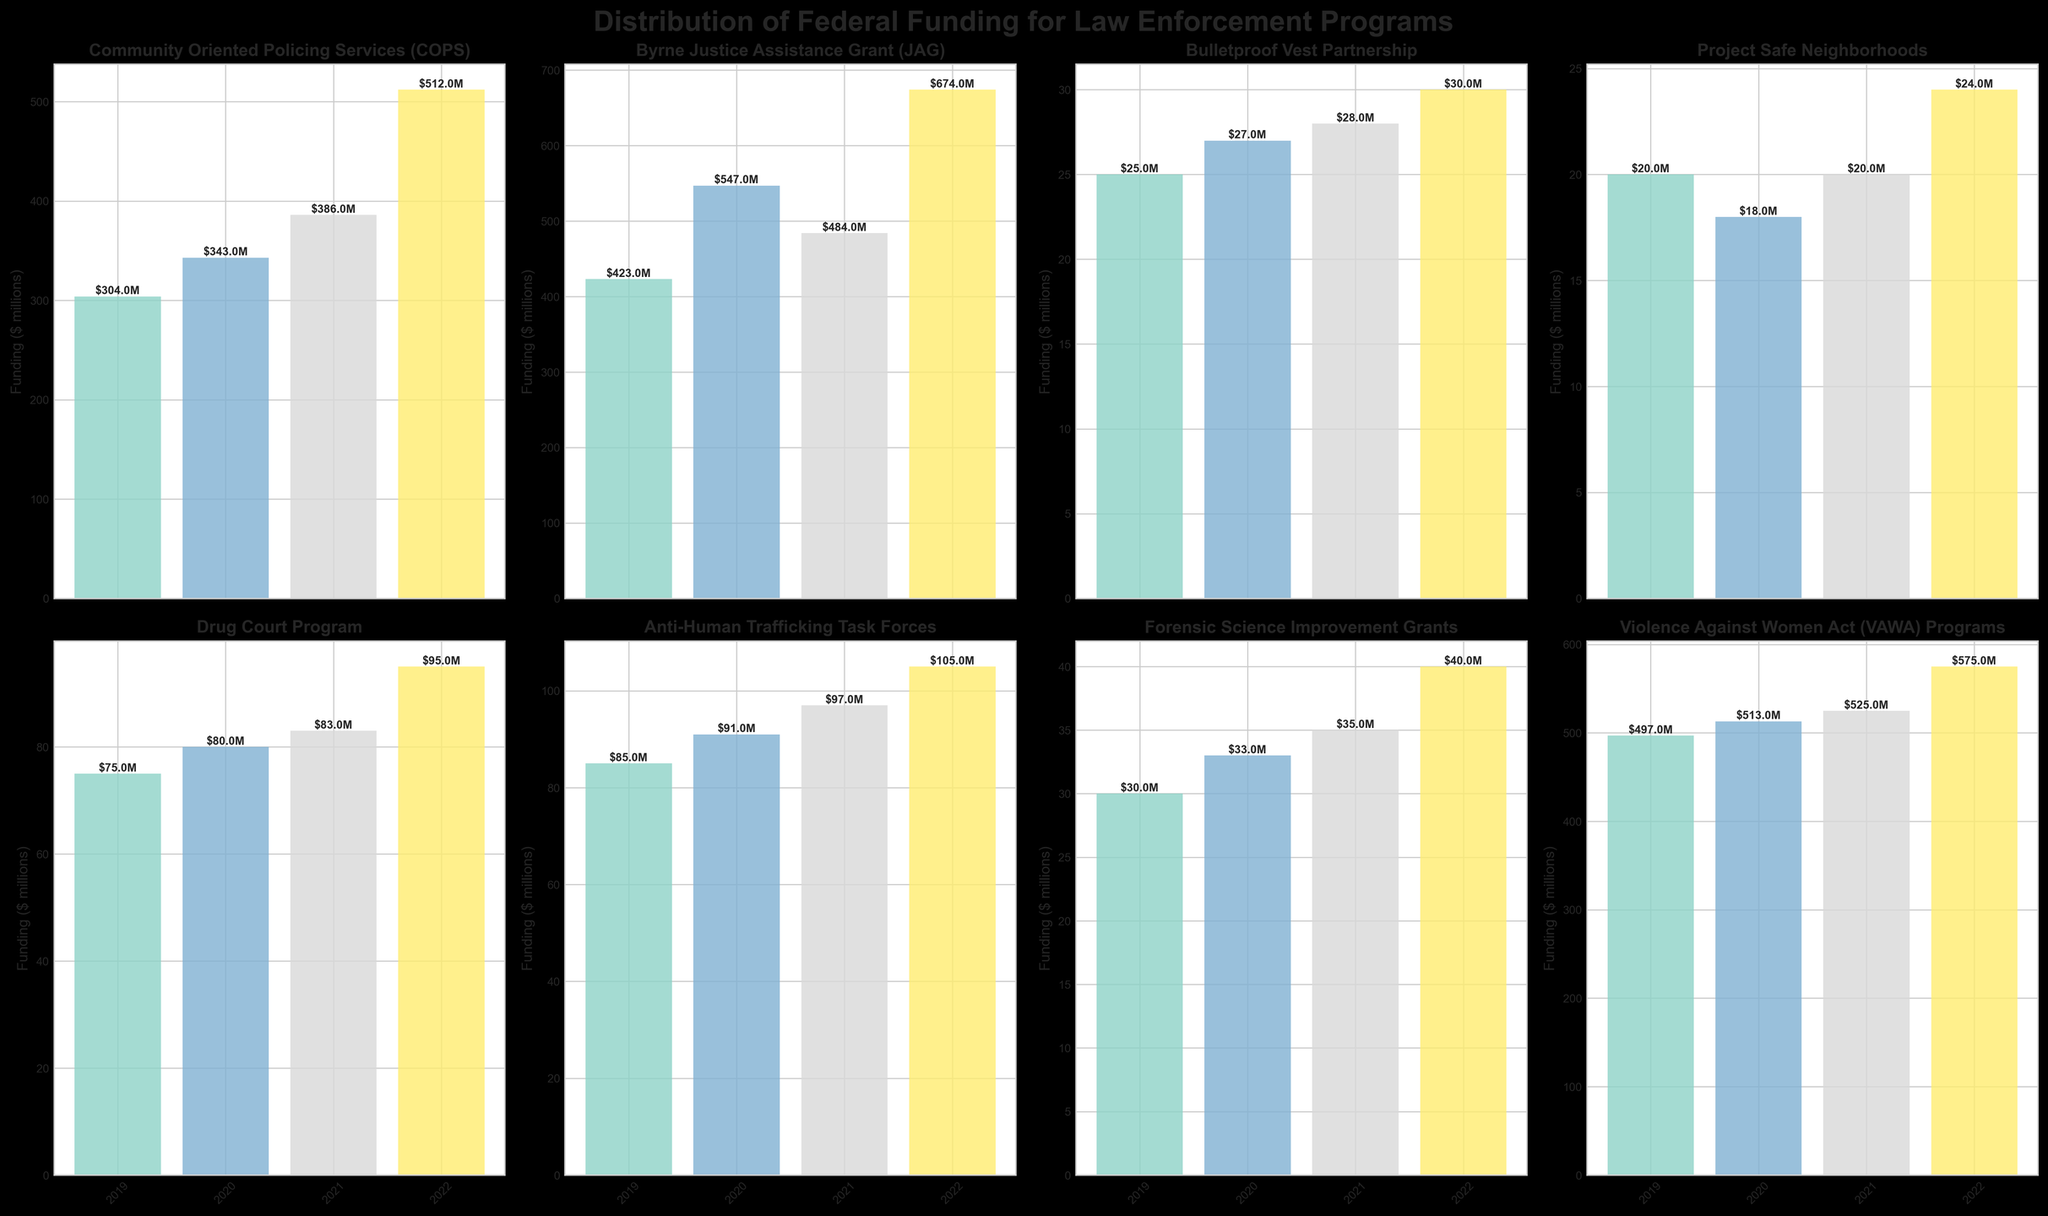What is the title of the figure? The title appears at the top of the figure and is typically the largest text. In this case, it is written bold and centered at the top.
Answer: Distribution of Federal Funding for Law Enforcement Programs How many subplots are there in the main figure? There are individual bar charts representing each program, arranged in a grid layout. By counting them, we see there are 8.
Answer: 8 Which program received the most funding in 2022? By examining the tallest bar for the year 2022 in each subplot, the subplot for "Byrne Justice Assistance Grant (JAG)" has the tallest bar.
Answer: Byrne Justice Assistance Grant (JAG) What is the funding for the Bulletproof Vest Partnership program in 2021? Locate the bar for the year 2021 in the Bulletproof Vest Partnership subplot. The bar is labeled with the funding amount.
Answer: $28M Which program had the smallest increase in funding from 2019 to 2020? To determine the smallest increase, compare the difference between the heights of the 2019 and 2020 bars for each subplot. "Project Safe Neighborhoods" shows the smallest increase in height between these years.
Answer: Project Safe Neighborhoods What is the average funding for the Anti-Human Trafficking Task Forces from 2019 to 2022? Add the values for Anti-Human Trafficking Task Forces from 2019 to 2022 and divide by the number of years: (85 + 91 + 97 + 105) / 4 = 378 / 4 = 94.5.
Answer: $94.5M Which program has the most consistent funding across the years 2019 to 2022? The most consistent funding would appear as bars of nearly equal height across the years. "Bulletproof Vest Partnership" has bars that are very close in height from 2019 to 2022.
Answer: Bulletproof Vest Partnership How much more funding did the Violence Against Women Act (VAWA) Programs receive compared to the Drug Court Program in 2022? Subtract the 2022 funding of the Drug Court Program from that of the Violence Against Women Act (VAWA) Programs: 575 - 95 = 480.
Answer: $480M 